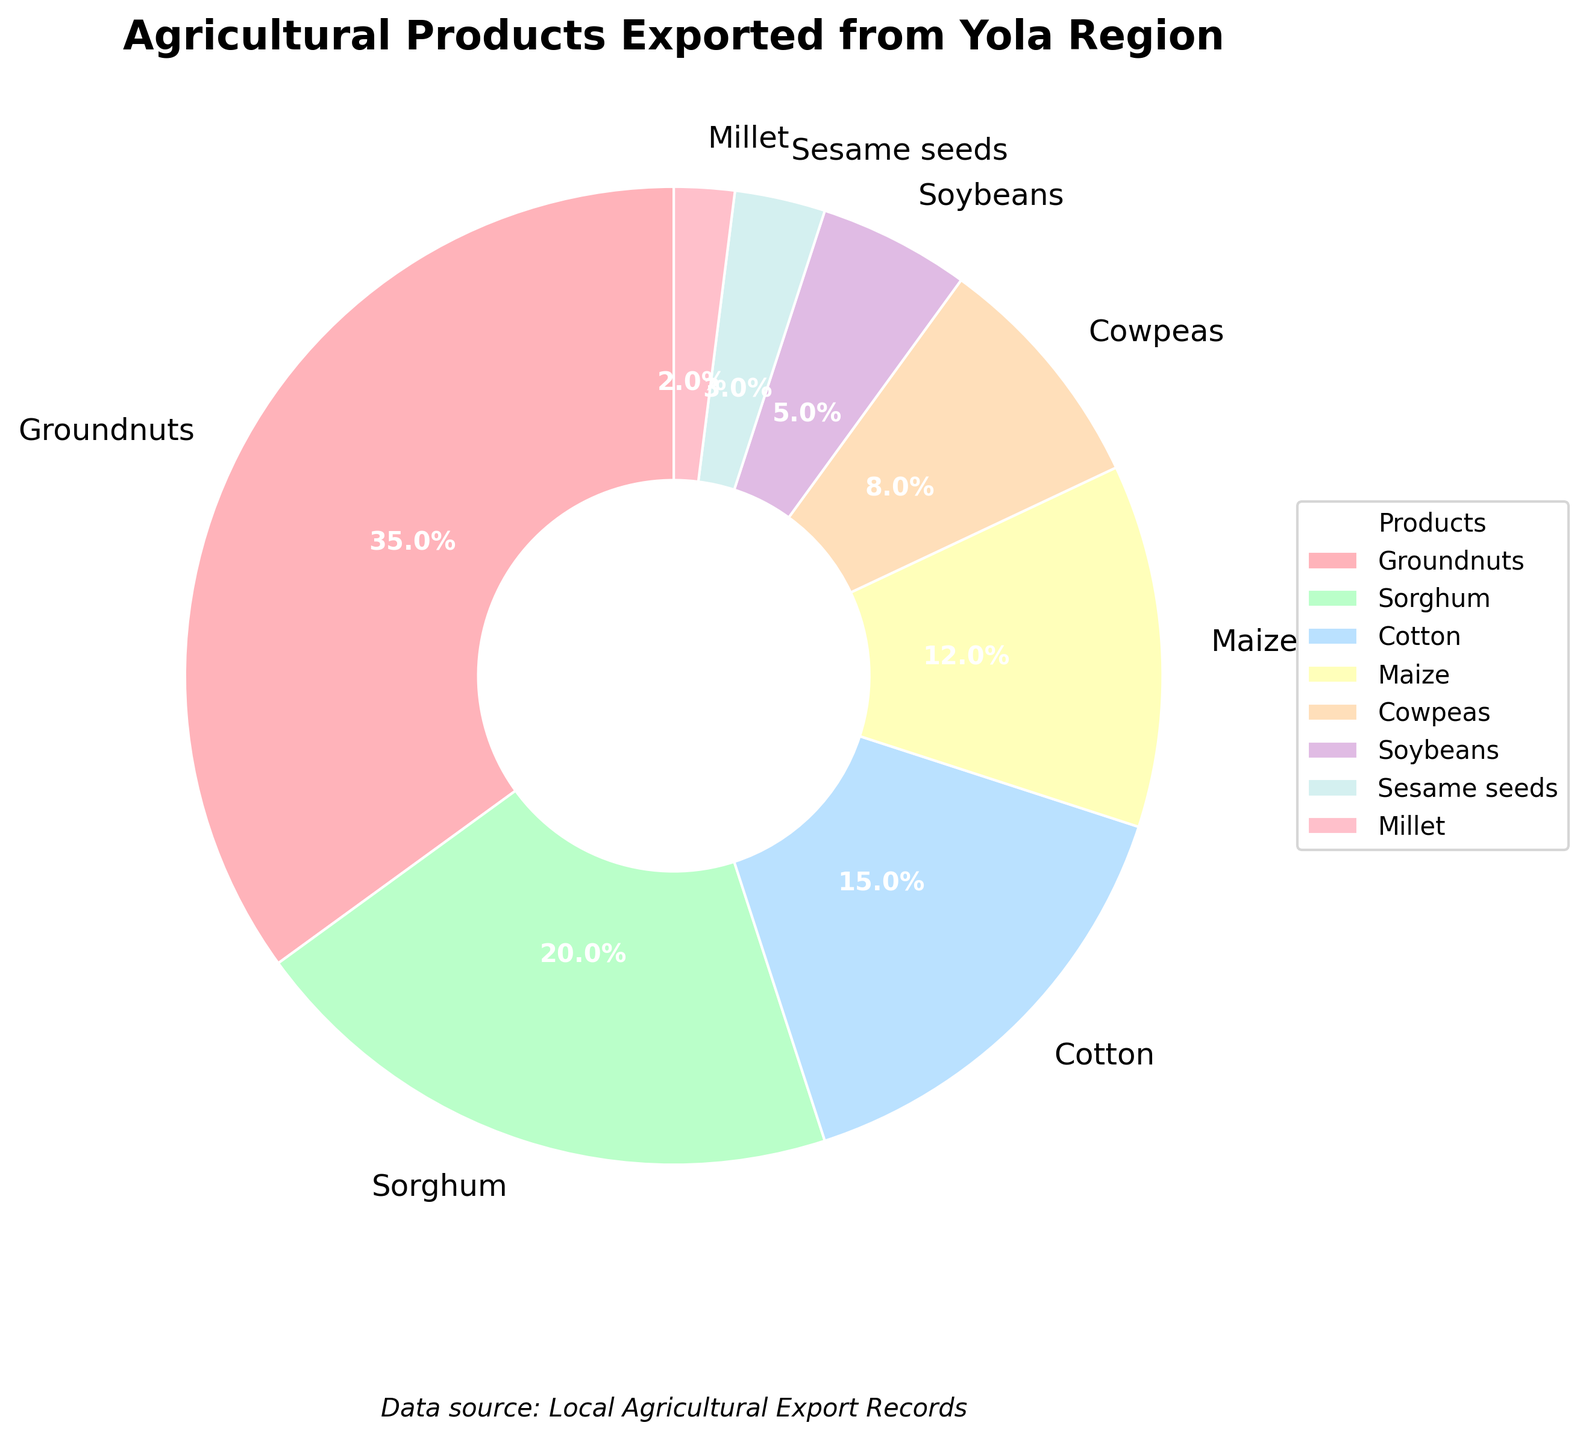Which agricultural product has the highest export percentage? The pie chart shows the percentage share for each agricultural product. The largest slice corresponds to Groundnuts.
Answer: Groundnuts By how much percentage does Sorghum's export exceed that of Soybeans? Sorghum's export percentage is 20%, while Soybeans' export percentage is 5%. Subtracting Soybeans' percentage from Sorghum's gives 20% - 5% = 15%.
Answer: 15% What is the combined export percentage of Cotton and Maize? The chart shows Cotton at 15% and Maize at 12%. Adding these together gives 15% + 12% = 27%.
Answer: 27% Which product contributes less to exports: Cowpeas or Sesame seeds? The export percentages for Cowpeas and Sesame seeds are shown as 8% and 3%, respectively. 3% is less than 8%.
Answer: Sesame seeds If the export percentage of Groundnuts and Millet are swapped, what would be the new export percentage of Groundnuts? Groundnuts currently has 35% and Millet has 2%. Swapping them means Groundnuts would now be 2%.
Answer: 2% Among the displayed products, which ones combined make up less than 10% of the total exports? The products and their percentages below 10% are Sesame seeds (3%) and Millet (2%). Adding these together gives 3% + 2% = 5%, which is less than 10%.
Answer: Sesame seeds, Millet In terms of export percentage, how does Maize compare with Cotton? The pie chart shows that Maize accounts for 12% and Cotton accounts for 15%. 12% is less than 15%.
Answer: Maize is less What’s the percentage difference between the highest and lowest exporting products? The highest exporting product is Groundnuts at 35% and the lowest is Millet at 2%. The difference is 35% - 2% = 33%.
Answer: 33% What is the visual feature that distinguishes Millet from other products? The pie chart uses different colors for each product. Millet is represented by a specific color wedge that is visibly smaller compared to others.
Answer: Smaller wedge Which products collectively constitute more than half of the total exports? The contributions of Groundnuts (35%), Sorghum (20%), and Cotton (15%) add up to more than half of the total (35% + 20% + 15% = 70%).
Answer: Groundnuts, Sorghum, Cotton 